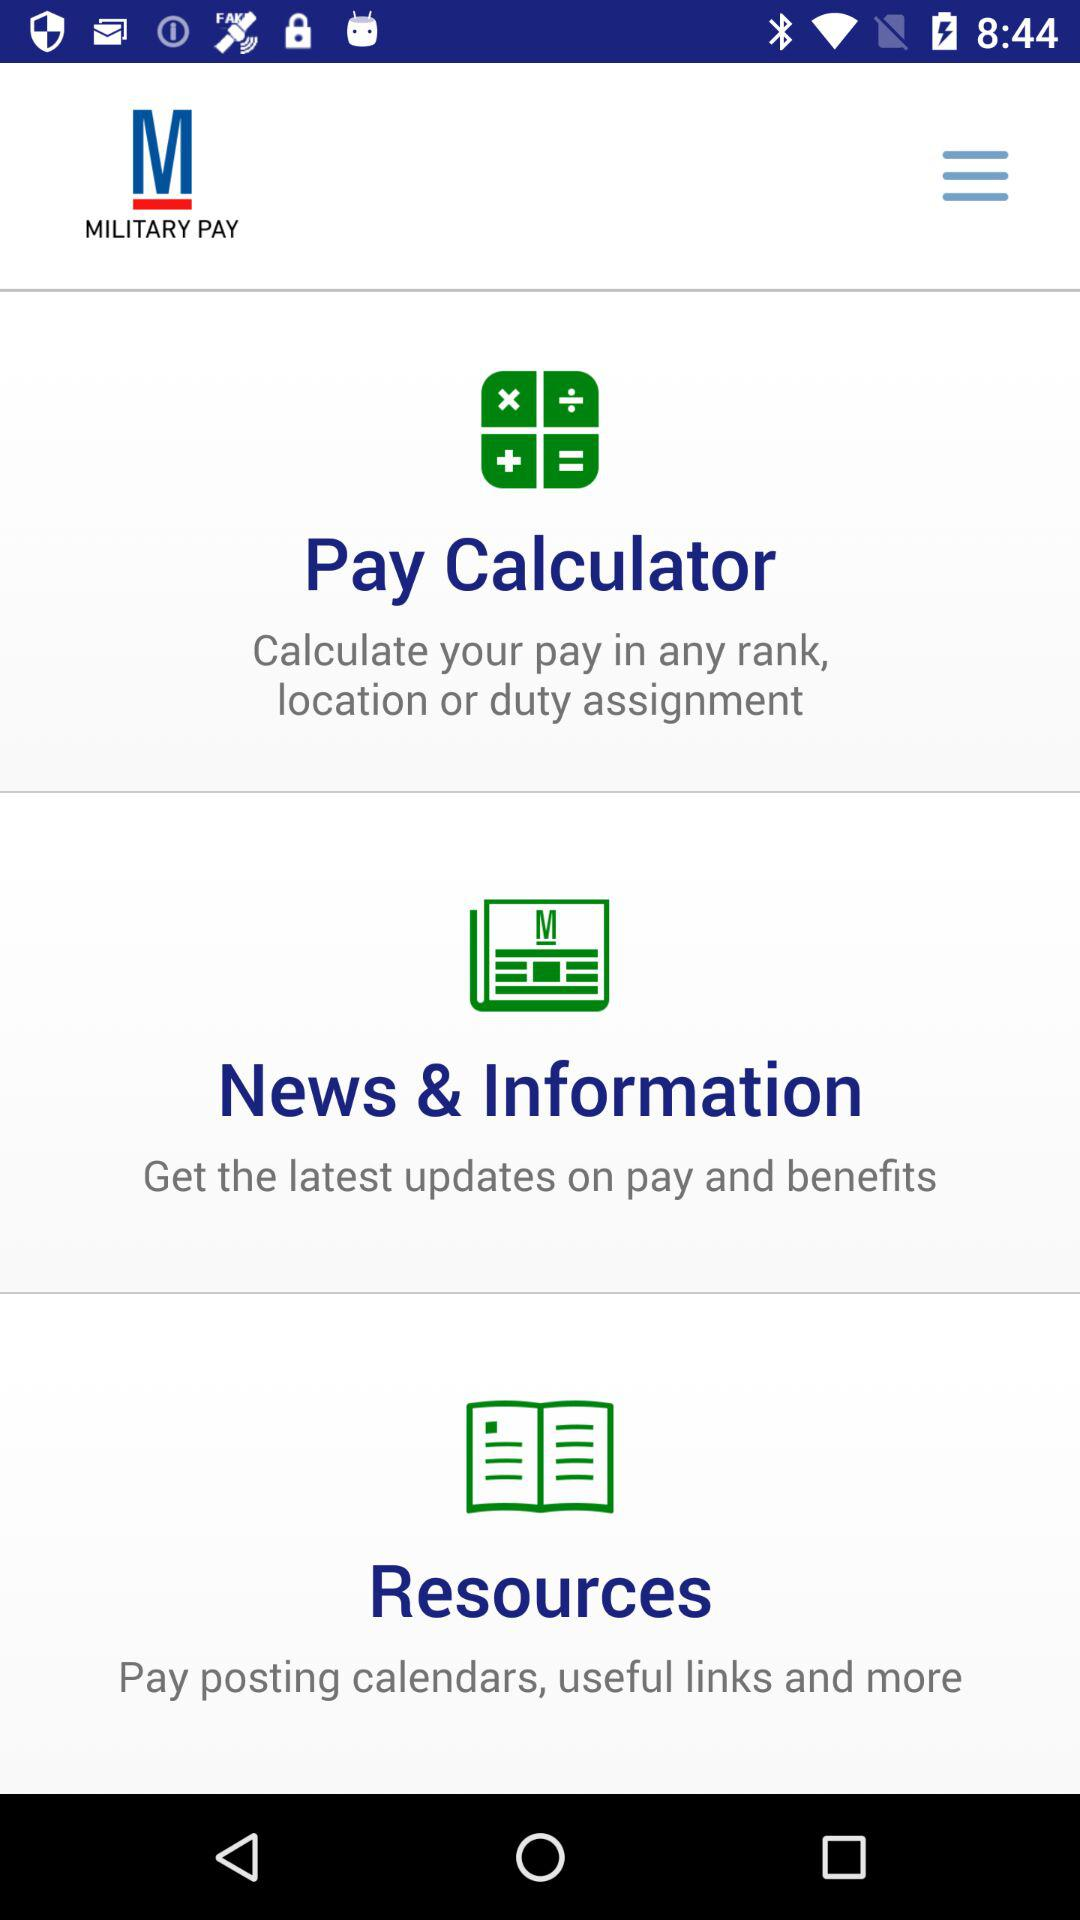What is the name of the application? The name of the application is Military Pay. 